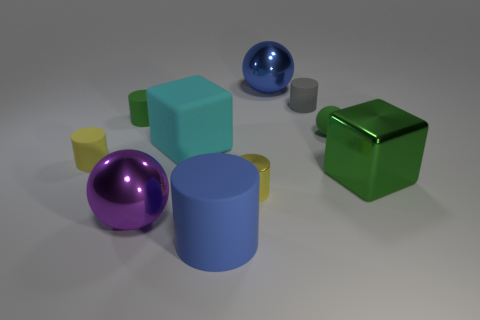Is the number of big blue matte things that are behind the big rubber block greater than the number of metallic things right of the small gray rubber cylinder? After carefully examining the objects in the image, the number of big blue matte objects located behind the big rubber block is not greater than the number of metallic things to the right of the small gray rubber cylinder. Specifically, there is one big blue matte sphere behind the big cyan rubber cube, whereas there are multiple metallic objects to the right of the small cylinder, including a metallic cube and a metallic cylinder. 